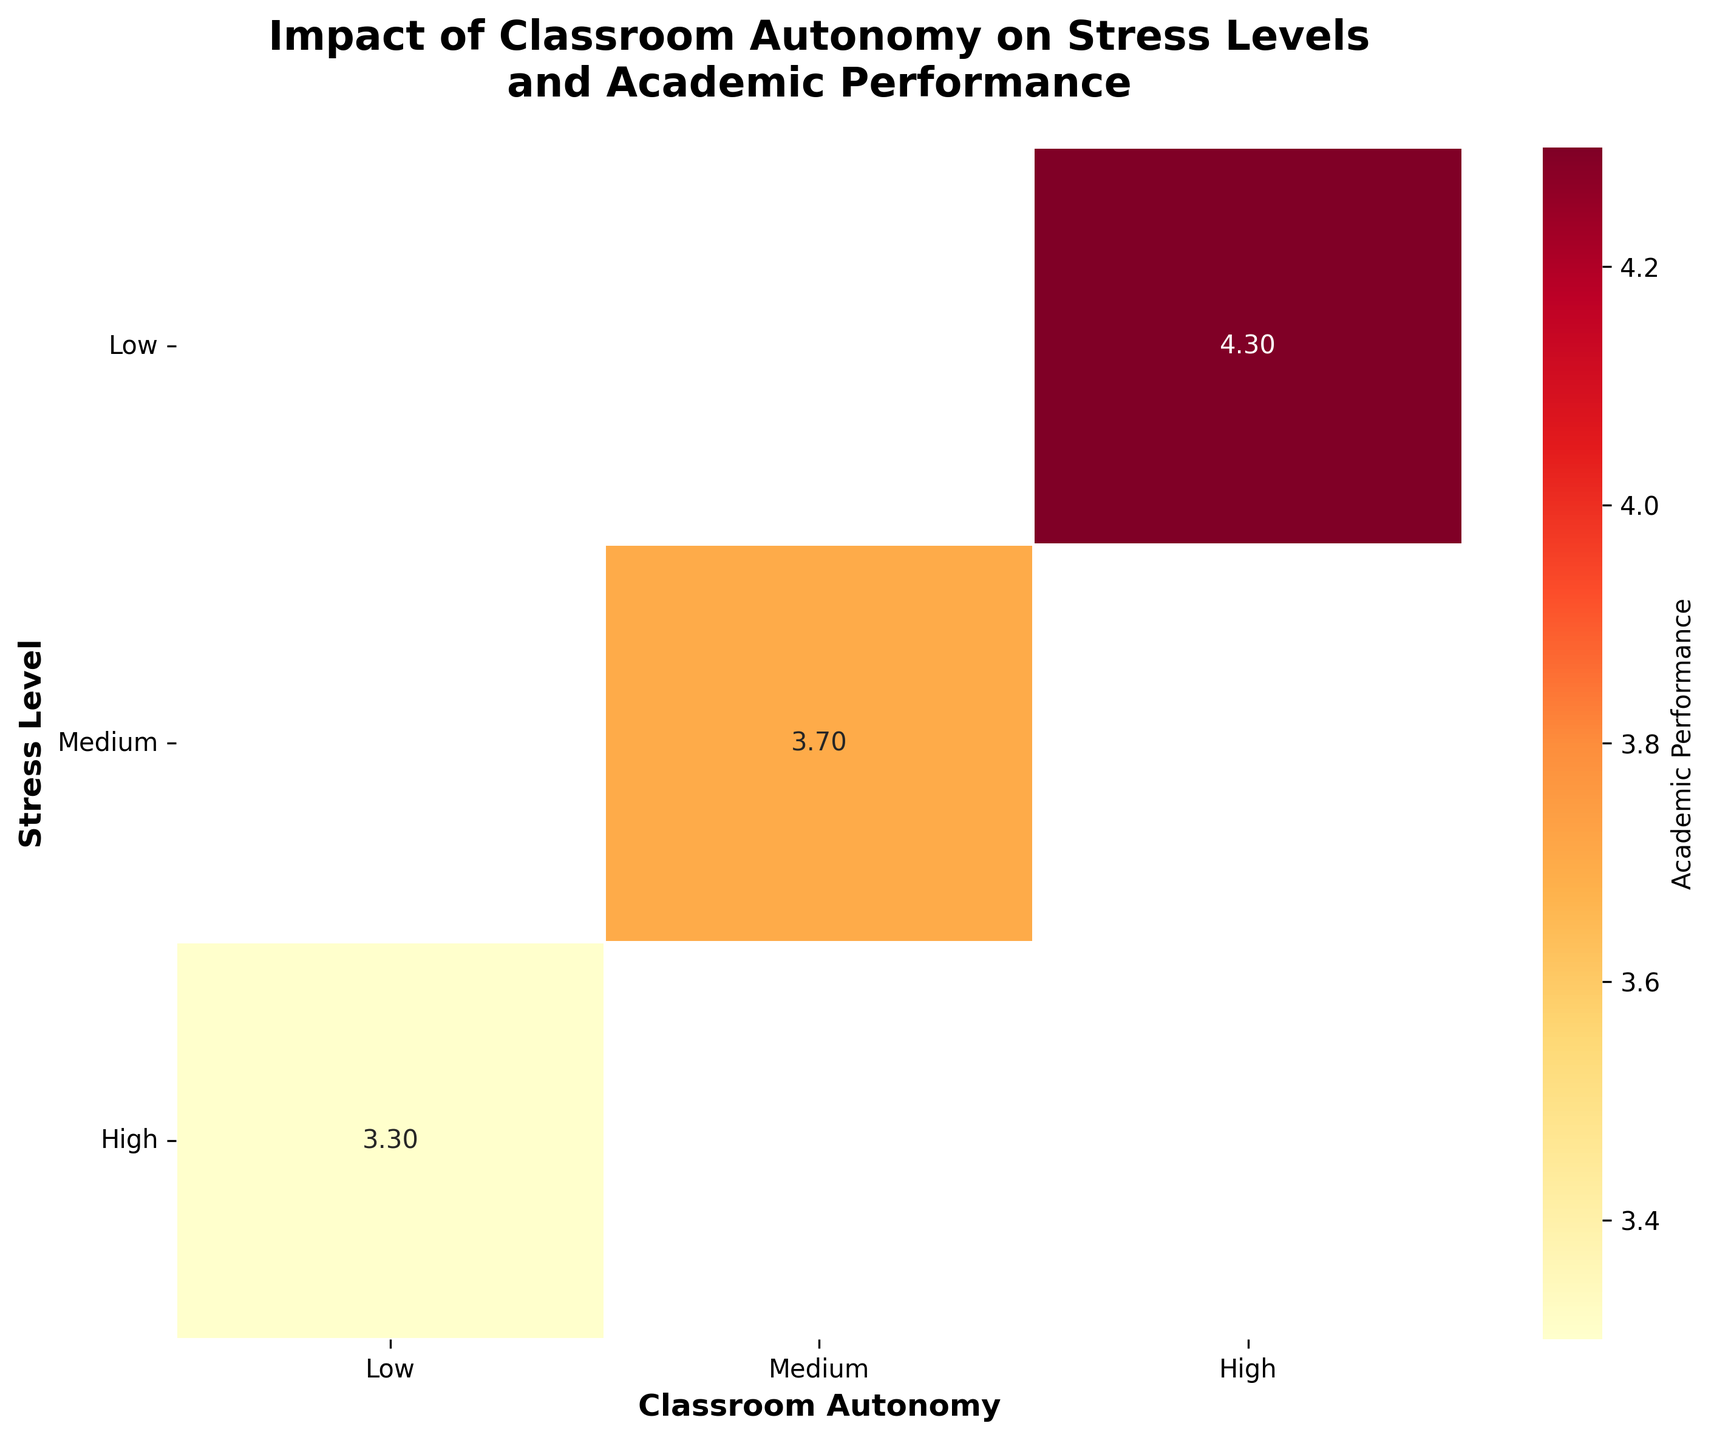What's the title of the heatmap? The title of the heatmap is usually displayed at the top center of the figure. In this case, it states the topic which is "Impact of Classroom Autonomy on Stress Levels and Academic Performance".
Answer: Impact of Classroom Autonomy on Stress Levels and Academic Performance What's the average academic performance for students with high stress levels and medium classroom autonomy? Find the cell that aligns with "High" stress level and "Medium" autonomy, and read the value from the heatmap.
Answer: 3.5 Which group has the highest academic performance, low stress level or high stress level students with high classroom autonomy? Compare the academic performance for "Low" and "High" stress levels under "High" classroom autonomy. The value for low stress is 4.5, and for high stress it is absent.
Answer: Low stress level students with high classroom autonomy What is the relationship between classroom autonomy and academic performance for students with low stress levels? Examine the row for "Low" stress level and observe how academic performance changes across different levels of autonomy. The values are 4.3 and 4.4 for medium and high autonomy respectively.
Answer: Academic performance increases with higher classroom autonomy If a student’s academic performance is 3.5, under which combination of stress level and classroom autonomy could this occur? Locate the value 3.5 on the heatmap. It appears at the intersection of "Medium" stress level and "Medium" autonomy.
Answer: Medium stress level and Medium classroom autonomy How does academic performance change as stress levels increase, under low classroom autonomy? Look at the column for "Low" classroom autonomy and observe academic performance values across different stress levels. The values are 3.2, 3.3, and 3.1.
Answer: It decreases What's the average academic performance among all groups with medium classroom autonomy? Find the column corresponding to medium autonomy and average the values: (3.8 + 3.6 + 3.9 + 3.7 + 3.5) / 5.
Answer: 3.7 Which combination of stress level and classroom autonomy shows the lowest academic performance? Identify the cell with the lowest value on the heatmap. The lowest value is 3.1 for high stress level and low autonomy.
Answer: High stress level and low classroom autonomy 